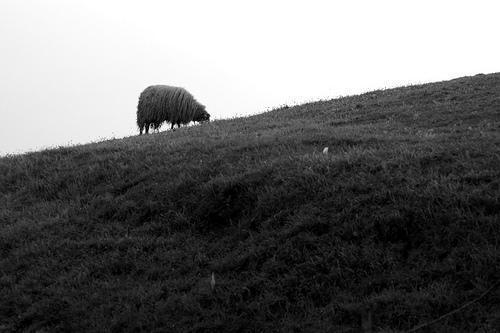How many sheep are pictured?
Give a very brief answer. 1. How many legs of the sheep are visible?
Give a very brief answer. 4. How many sheep are in the photo?
Give a very brief answer. 1. 